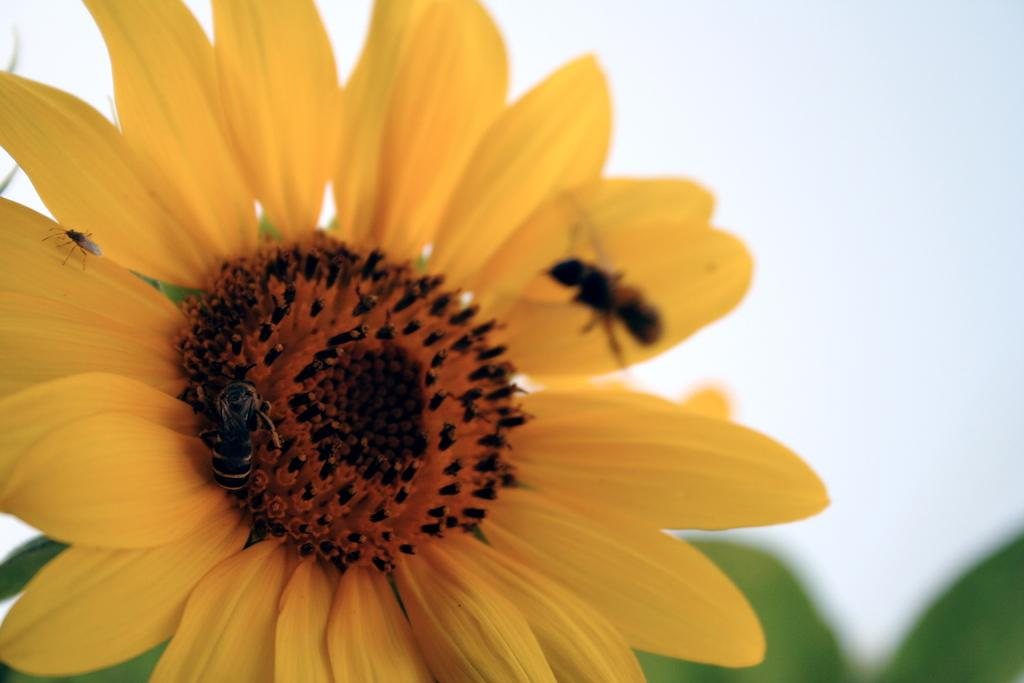What is the main subject of the picture? The main subject of the picture is a flower. Are there any other living organisms present on the flower? Yes, there are honey bees on the flower. What else can be seen in the picture besides the flower and honey bees? Leaves are visible in the picture. How would you describe the weather based on the sky in the picture? The sky is cloudy in the picture, which suggests overcast or potentially rainy weather. What type of dress is the flower wearing in the image? There is no dress present in the image, as flowers do not wear clothing. 